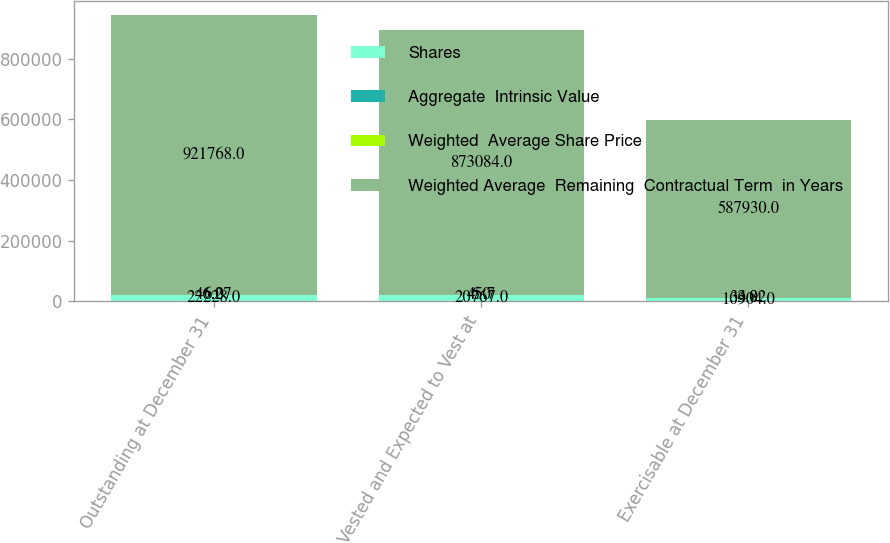Convert chart to OTSL. <chart><loc_0><loc_0><loc_500><loc_500><stacked_bar_chart><ecel><fcel>Outstanding at December 31<fcel>Vested and Expected to Vest at<fcel>Exercisable at December 31<nl><fcel>Shares<fcel>22228<fcel>20767<fcel>10904<nl><fcel>Aggregate  Intrinsic Value<fcel>46.27<fcel>45.7<fcel>33.82<nl><fcel>Weighted  Average Share Price<fcel>6<fcel>6<fcel>4<nl><fcel>Weighted Average  Remaining  Contractual Term  in Years<fcel>921768<fcel>873084<fcel>587930<nl></chart> 